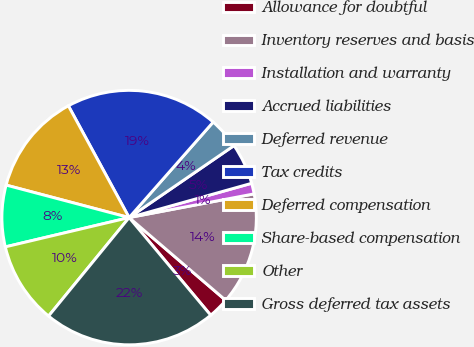Convert chart to OTSL. <chart><loc_0><loc_0><loc_500><loc_500><pie_chart><fcel>Allowance for doubtful<fcel>Inventory reserves and basis<fcel>Installation and warranty<fcel>Accrued liabilities<fcel>Deferred revenue<fcel>Tax credits<fcel>Deferred compensation<fcel>Share-based compensation<fcel>Other<fcel>Gross deferred tax assets<nl><fcel>2.65%<fcel>14.26%<fcel>1.36%<fcel>5.23%<fcel>3.94%<fcel>19.41%<fcel>12.97%<fcel>7.81%<fcel>10.39%<fcel>21.99%<nl></chart> 